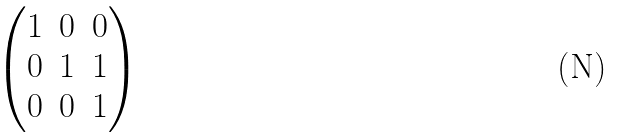<formula> <loc_0><loc_0><loc_500><loc_500>\begin{pmatrix} 1 & 0 & 0 \\ 0 & 1 & 1 \\ 0 & 0 & 1 \end{pmatrix}</formula> 